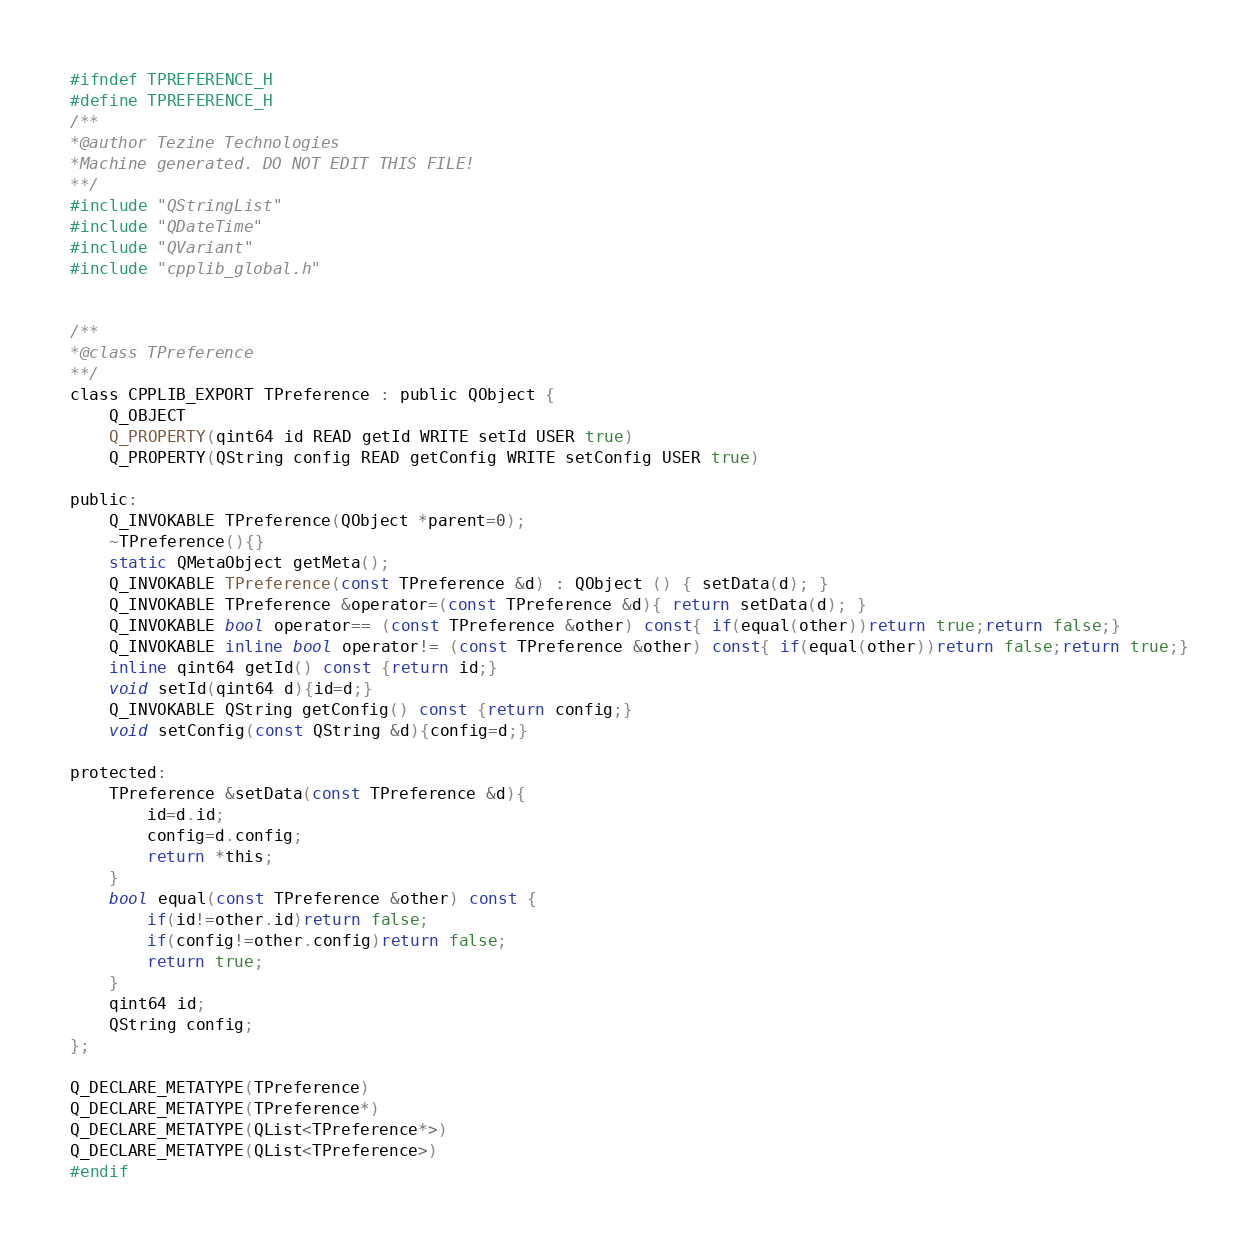<code> <loc_0><loc_0><loc_500><loc_500><_C_>#ifndef TPREFERENCE_H
#define TPREFERENCE_H
/**
*@author Tezine Technologies
*Machine generated. DO NOT EDIT THIS FILE!
**/
#include "QStringList"
#include "QDateTime"
#include "QVariant"
#include "cpplib_global.h"


/**
*@class TPreference
**/
class CPPLIB_EXPORT TPreference : public QObject {
	Q_OBJECT
	Q_PROPERTY(qint64 id READ getId WRITE setId USER true)
	Q_PROPERTY(QString config READ getConfig WRITE setConfig USER true)

public:
	Q_INVOKABLE TPreference(QObject *parent=0);
	~TPreference(){}
	static QMetaObject getMeta();
	Q_INVOKABLE TPreference(const TPreference &d) : QObject () { setData(d); }
	Q_INVOKABLE TPreference &operator=(const TPreference &d){ return setData(d); }
	Q_INVOKABLE bool operator== (const TPreference &other) const{ if(equal(other))return true;return false;}
	Q_INVOKABLE inline bool operator!= (const TPreference &other) const{ if(equal(other))return false;return true;}
	inline qint64 getId() const {return id;}
	void setId(qint64 d){id=d;}
	Q_INVOKABLE QString getConfig() const {return config;}
	void setConfig(const QString &d){config=d;}

protected:
	TPreference &setData(const TPreference &d){
		id=d.id;
		config=d.config;
		return *this;
	}
	bool equal(const TPreference &other) const {
		if(id!=other.id)return false;
		if(config!=other.config)return false;
		return true;
	}
	qint64 id;
	QString config;
};

Q_DECLARE_METATYPE(TPreference)
Q_DECLARE_METATYPE(TPreference*)
Q_DECLARE_METATYPE(QList<TPreference*>)
Q_DECLARE_METATYPE(QList<TPreference>)
#endif
</code> 